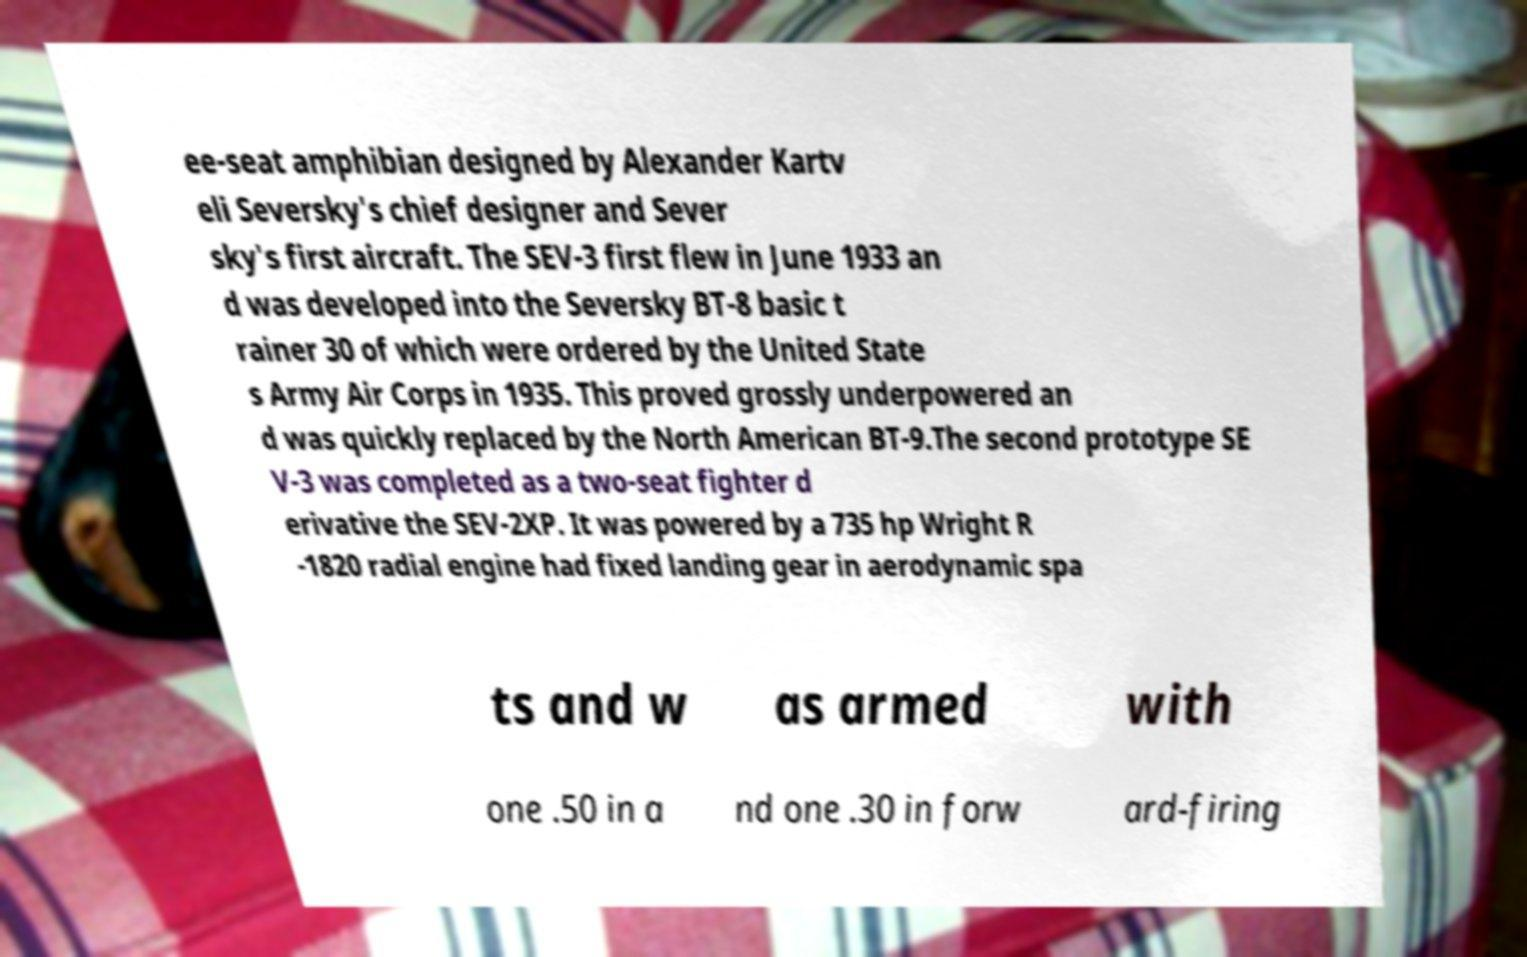Please identify and transcribe the text found in this image. ee-seat amphibian designed by Alexander Kartv eli Seversky's chief designer and Sever sky's first aircraft. The SEV-3 first flew in June 1933 an d was developed into the Seversky BT-8 basic t rainer 30 of which were ordered by the United State s Army Air Corps in 1935. This proved grossly underpowered an d was quickly replaced by the North American BT-9.The second prototype SE V-3 was completed as a two-seat fighter d erivative the SEV-2XP. It was powered by a 735 hp Wright R -1820 radial engine had fixed landing gear in aerodynamic spa ts and w as armed with one .50 in a nd one .30 in forw ard-firing 